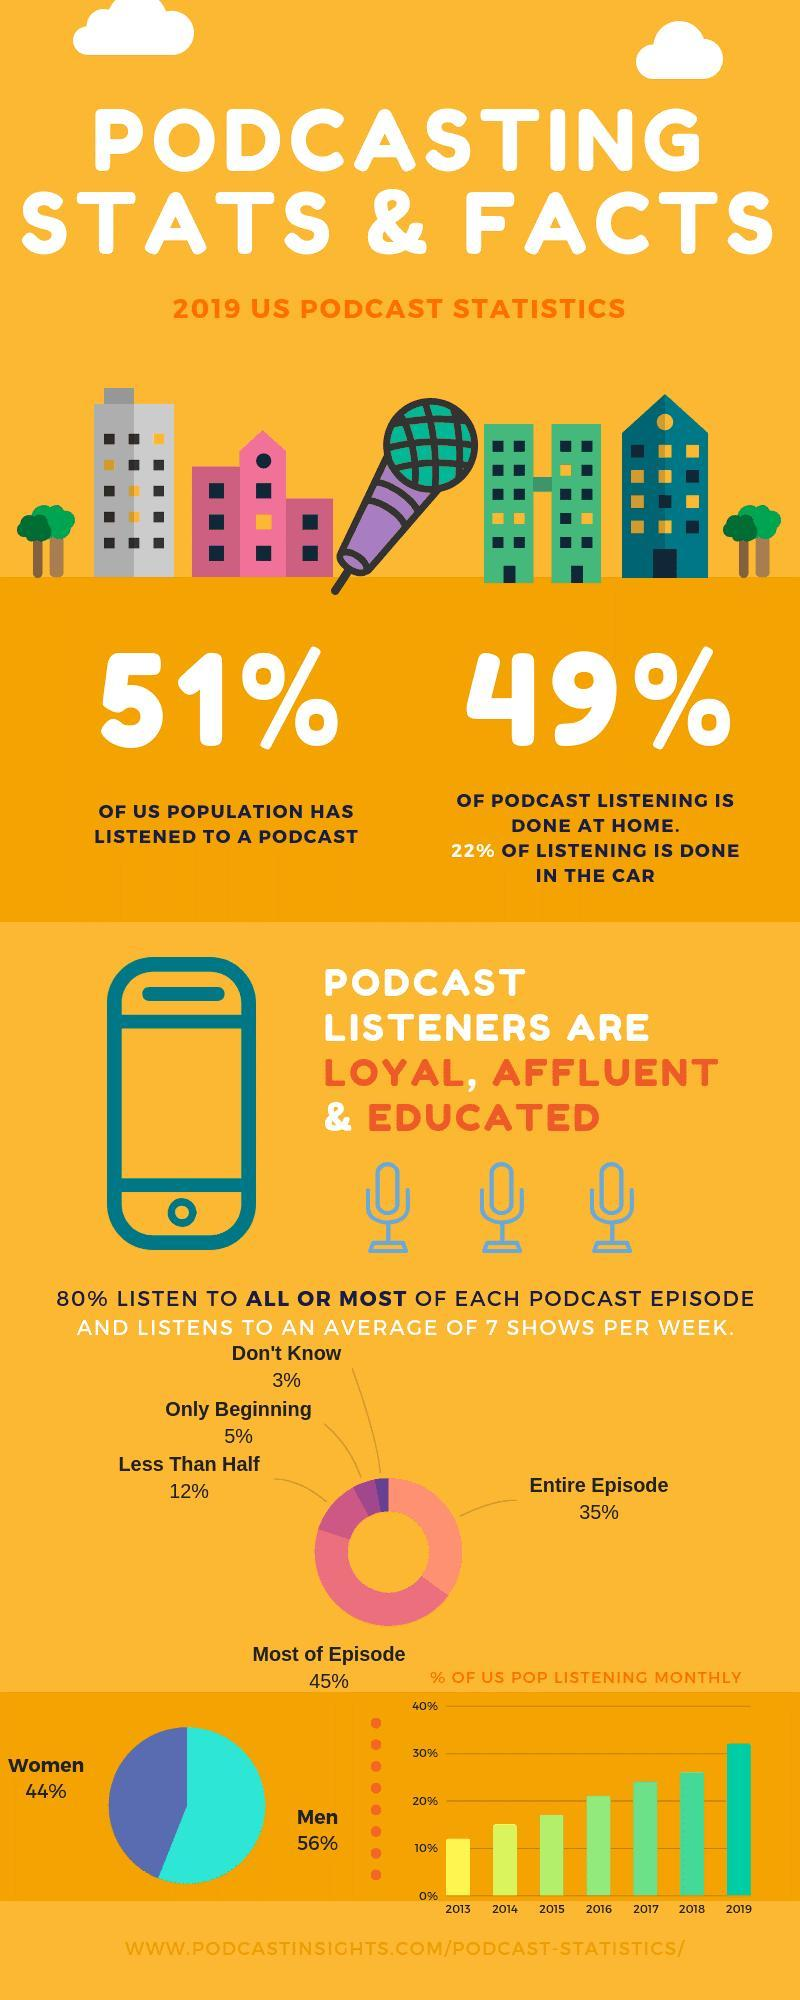Who has the highest share in listening podcasts- women, men?
Answer the question with a short phrase. men What percentage of the US population has not listened to a podcast? 49% What percentage of podcast listening is not at home? 51% Which has the highest share-entire episode, most of episode? most of episode 